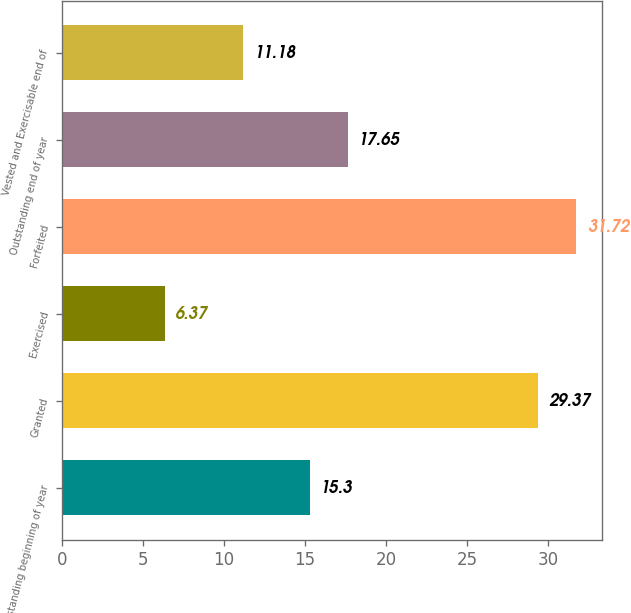Convert chart to OTSL. <chart><loc_0><loc_0><loc_500><loc_500><bar_chart><fcel>Outstanding beginning of year<fcel>Granted<fcel>Exercised<fcel>Forfeited<fcel>Outstanding end of year<fcel>Vested and Exercisable end of<nl><fcel>15.3<fcel>29.37<fcel>6.37<fcel>31.72<fcel>17.65<fcel>11.18<nl></chart> 